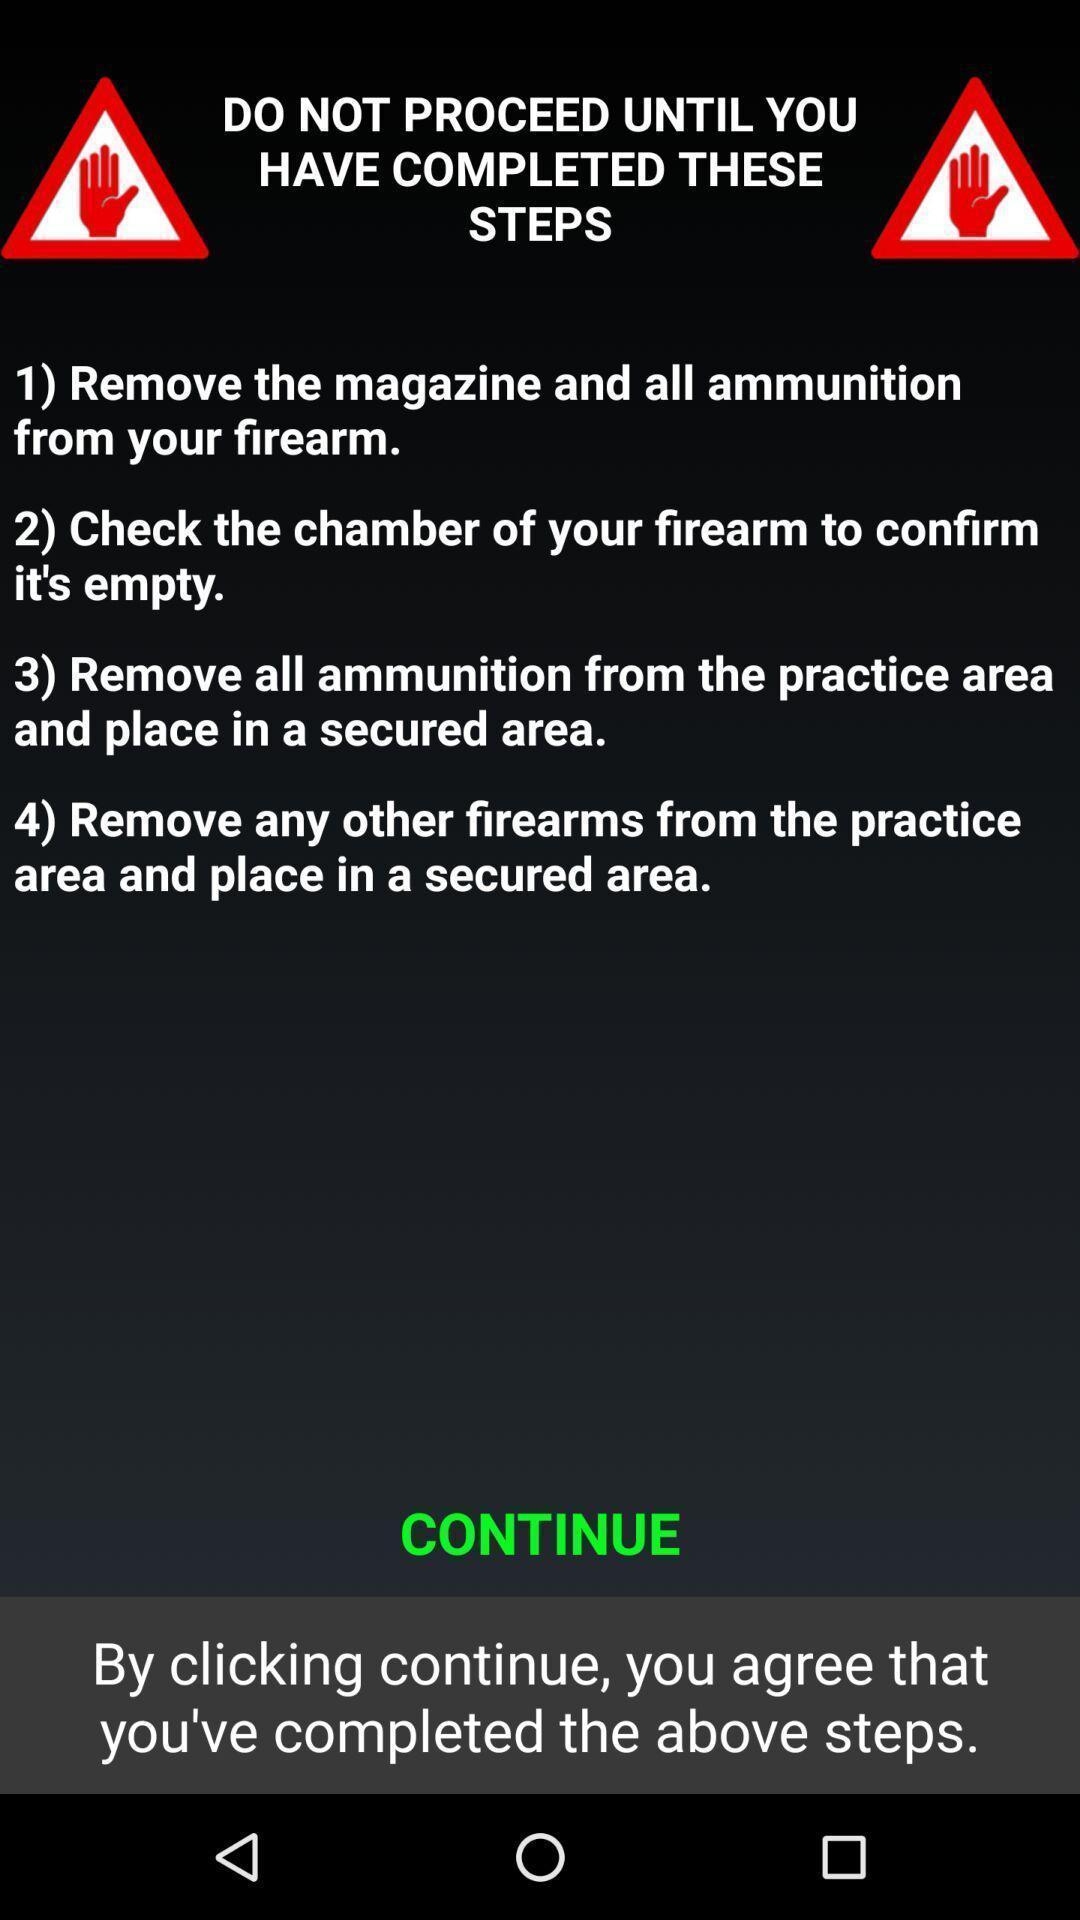Tell me what you see in this picture. Page showing some terms and conditions to continue. 